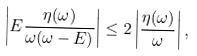<formula> <loc_0><loc_0><loc_500><loc_500>\left | E \frac { \eta ( \omega ) } { \omega ( \omega - E ) } \right | \leq 2 \left | \frac { \eta ( \omega ) } { \omega } \right | ,</formula> 